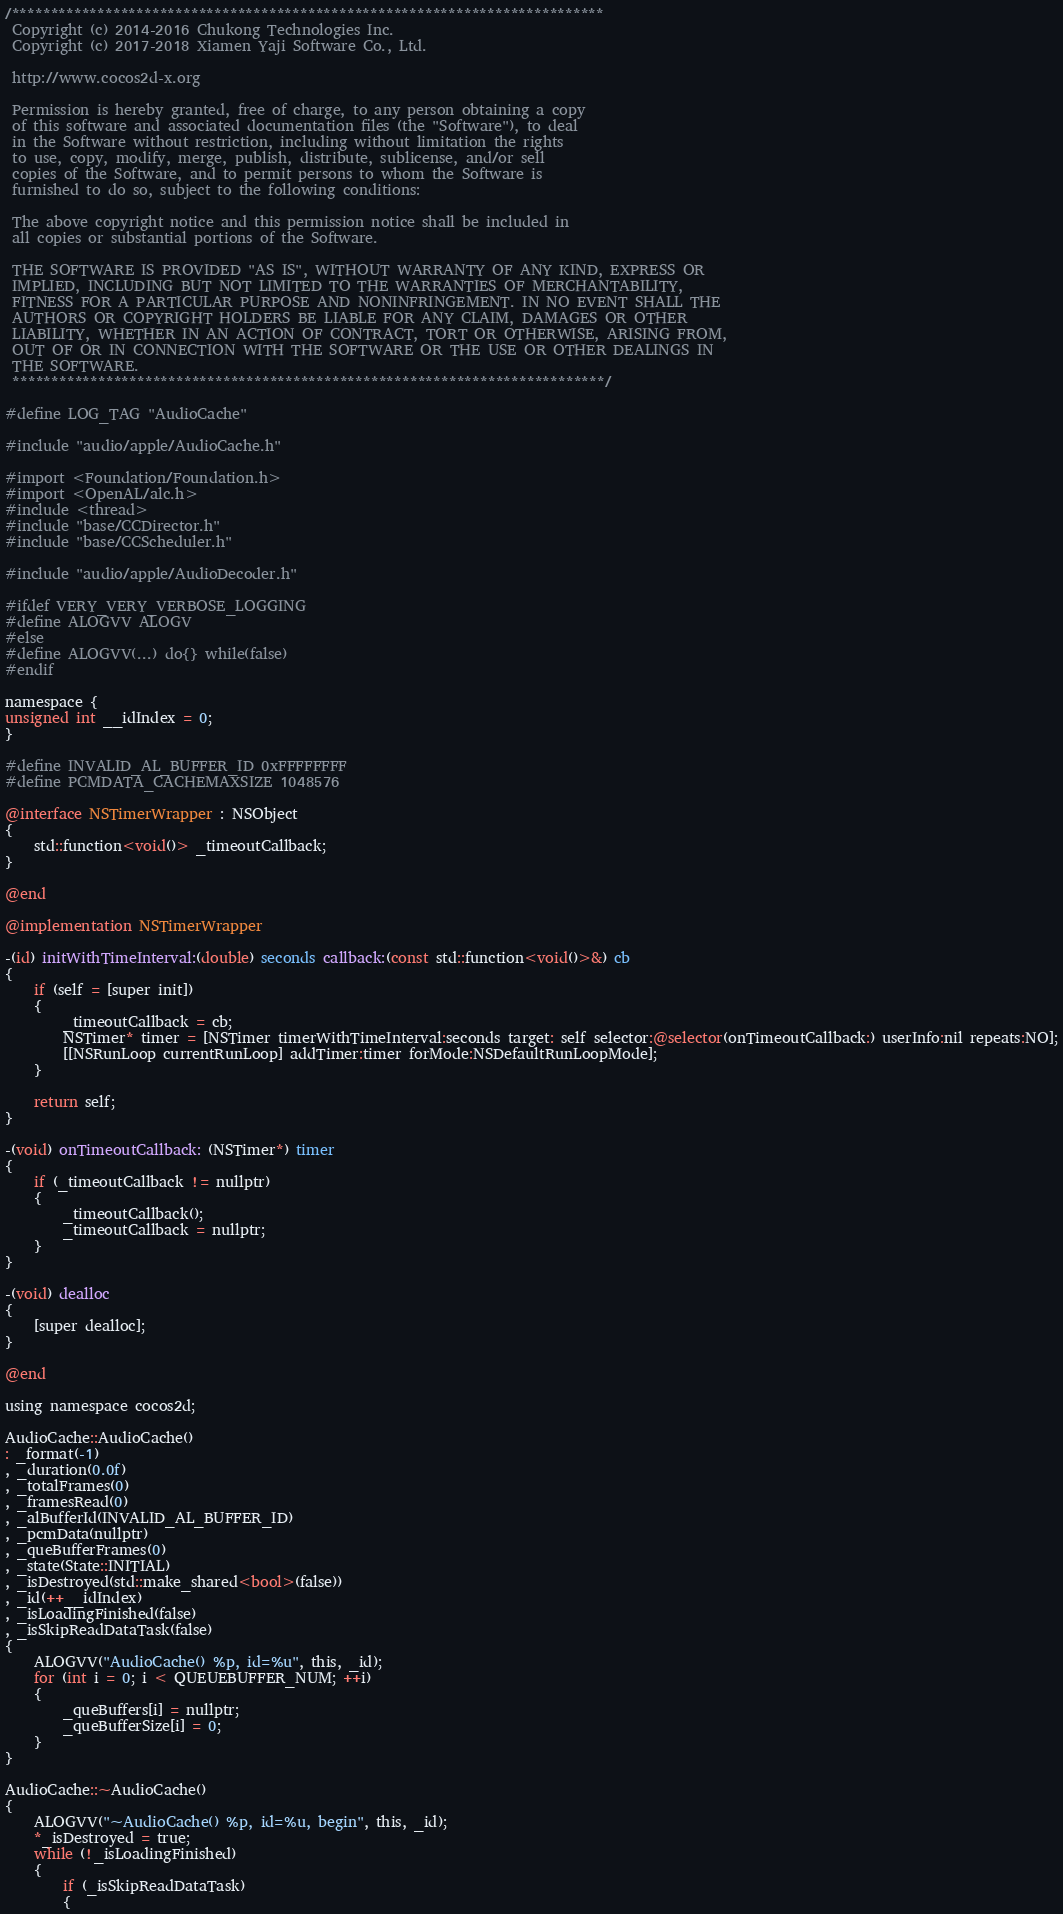Convert code to text. <code><loc_0><loc_0><loc_500><loc_500><_ObjectiveC_>/****************************************************************************
 Copyright (c) 2014-2016 Chukong Technologies Inc.
 Copyright (c) 2017-2018 Xiamen Yaji Software Co., Ltd.

 http://www.cocos2d-x.org

 Permission is hereby granted, free of charge, to any person obtaining a copy
 of this software and associated documentation files (the "Software"), to deal
 in the Software without restriction, including without limitation the rights
 to use, copy, modify, merge, publish, distribute, sublicense, and/or sell
 copies of the Software, and to permit persons to whom the Software is
 furnished to do so, subject to the following conditions:

 The above copyright notice and this permission notice shall be included in
 all copies or substantial portions of the Software.

 THE SOFTWARE IS PROVIDED "AS IS", WITHOUT WARRANTY OF ANY KIND, EXPRESS OR
 IMPLIED, INCLUDING BUT NOT LIMITED TO THE WARRANTIES OF MERCHANTABILITY,
 FITNESS FOR A PARTICULAR PURPOSE AND NONINFRINGEMENT. IN NO EVENT SHALL THE
 AUTHORS OR COPYRIGHT HOLDERS BE LIABLE FOR ANY CLAIM, DAMAGES OR OTHER
 LIABILITY, WHETHER IN AN ACTION OF CONTRACT, TORT OR OTHERWISE, ARISING FROM,
 OUT OF OR IN CONNECTION WITH THE SOFTWARE OR THE USE OR OTHER DEALINGS IN
 THE SOFTWARE.
 ****************************************************************************/

#define LOG_TAG "AudioCache"

#include "audio/apple/AudioCache.h"

#import <Foundation/Foundation.h>
#import <OpenAL/alc.h>
#include <thread>
#include "base/CCDirector.h"
#include "base/CCScheduler.h"

#include "audio/apple/AudioDecoder.h"

#ifdef VERY_VERY_VERBOSE_LOGGING
#define ALOGVV ALOGV
#else
#define ALOGVV(...) do{} while(false)
#endif

namespace {
unsigned int __idIndex = 0;
}

#define INVALID_AL_BUFFER_ID 0xFFFFFFFF
#define PCMDATA_CACHEMAXSIZE 1048576

@interface NSTimerWrapper : NSObject
{
    std::function<void()> _timeoutCallback;
}

@end

@implementation NSTimerWrapper

-(id) initWithTimeInterval:(double) seconds callback:(const std::function<void()>&) cb
{
    if (self = [super init])
    {
        _timeoutCallback = cb;
        NSTimer* timer = [NSTimer timerWithTimeInterval:seconds target: self selector:@selector(onTimeoutCallback:) userInfo:nil repeats:NO];
        [[NSRunLoop currentRunLoop] addTimer:timer forMode:NSDefaultRunLoopMode];
    }

    return self;
}

-(void) onTimeoutCallback: (NSTimer*) timer
{
    if (_timeoutCallback != nullptr)
    {
        _timeoutCallback();
        _timeoutCallback = nullptr;
    }
}

-(void) dealloc
{
    [super dealloc];
}

@end

using namespace cocos2d;

AudioCache::AudioCache()
: _format(-1)
, _duration(0.0f)
, _totalFrames(0)
, _framesRead(0)
, _alBufferId(INVALID_AL_BUFFER_ID)
, _pcmData(nullptr)
, _queBufferFrames(0)
, _state(State::INITIAL)
, _isDestroyed(std::make_shared<bool>(false))
, _id(++__idIndex)
, _isLoadingFinished(false)
, _isSkipReadDataTask(false)
{
    ALOGVV("AudioCache() %p, id=%u", this, _id);
    for (int i = 0; i < QUEUEBUFFER_NUM; ++i)
    {
        _queBuffers[i] = nullptr;
        _queBufferSize[i] = 0;
    }
}

AudioCache::~AudioCache()
{
    ALOGVV("~AudioCache() %p, id=%u, begin", this, _id);
    *_isDestroyed = true;
    while (!_isLoadingFinished)
    {
        if (_isSkipReadDataTask)
        {</code> 